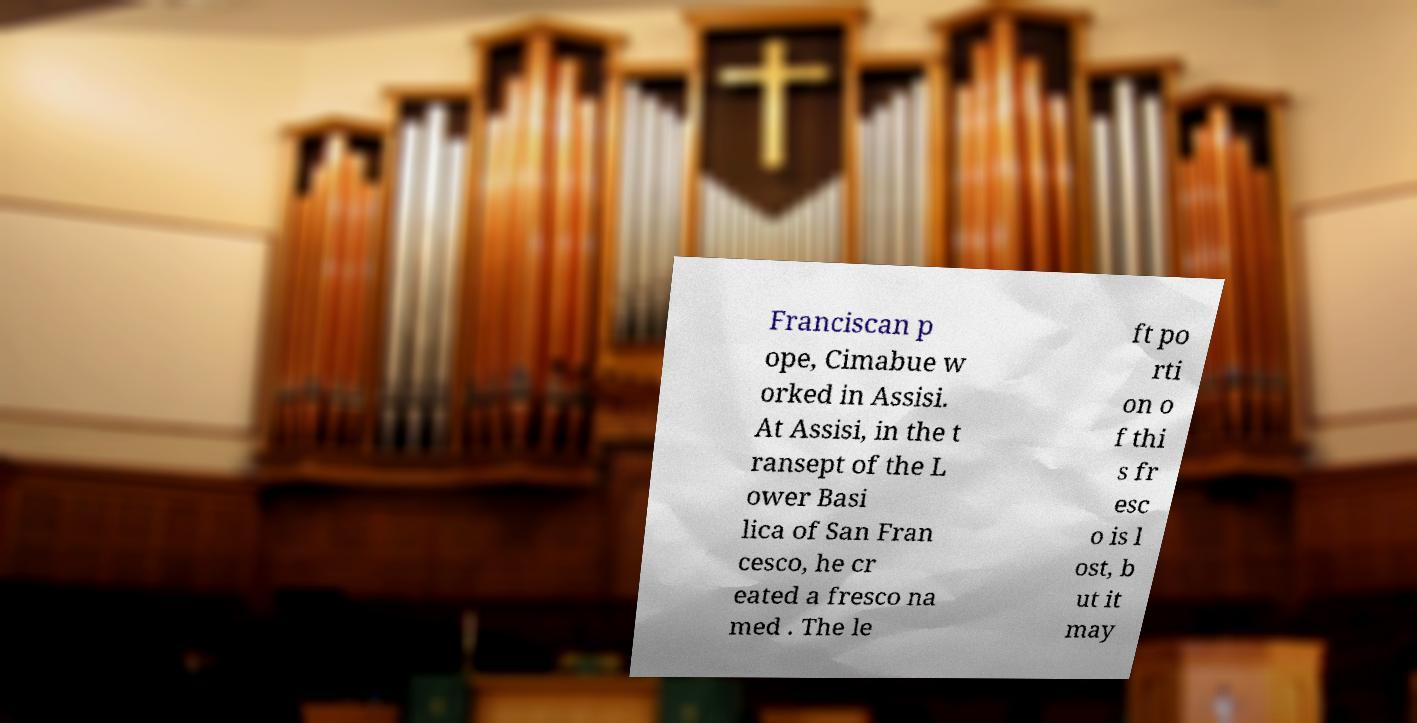There's text embedded in this image that I need extracted. Can you transcribe it verbatim? Franciscan p ope, Cimabue w orked in Assisi. At Assisi, in the t ransept of the L ower Basi lica of San Fran cesco, he cr eated a fresco na med . The le ft po rti on o f thi s fr esc o is l ost, b ut it may 